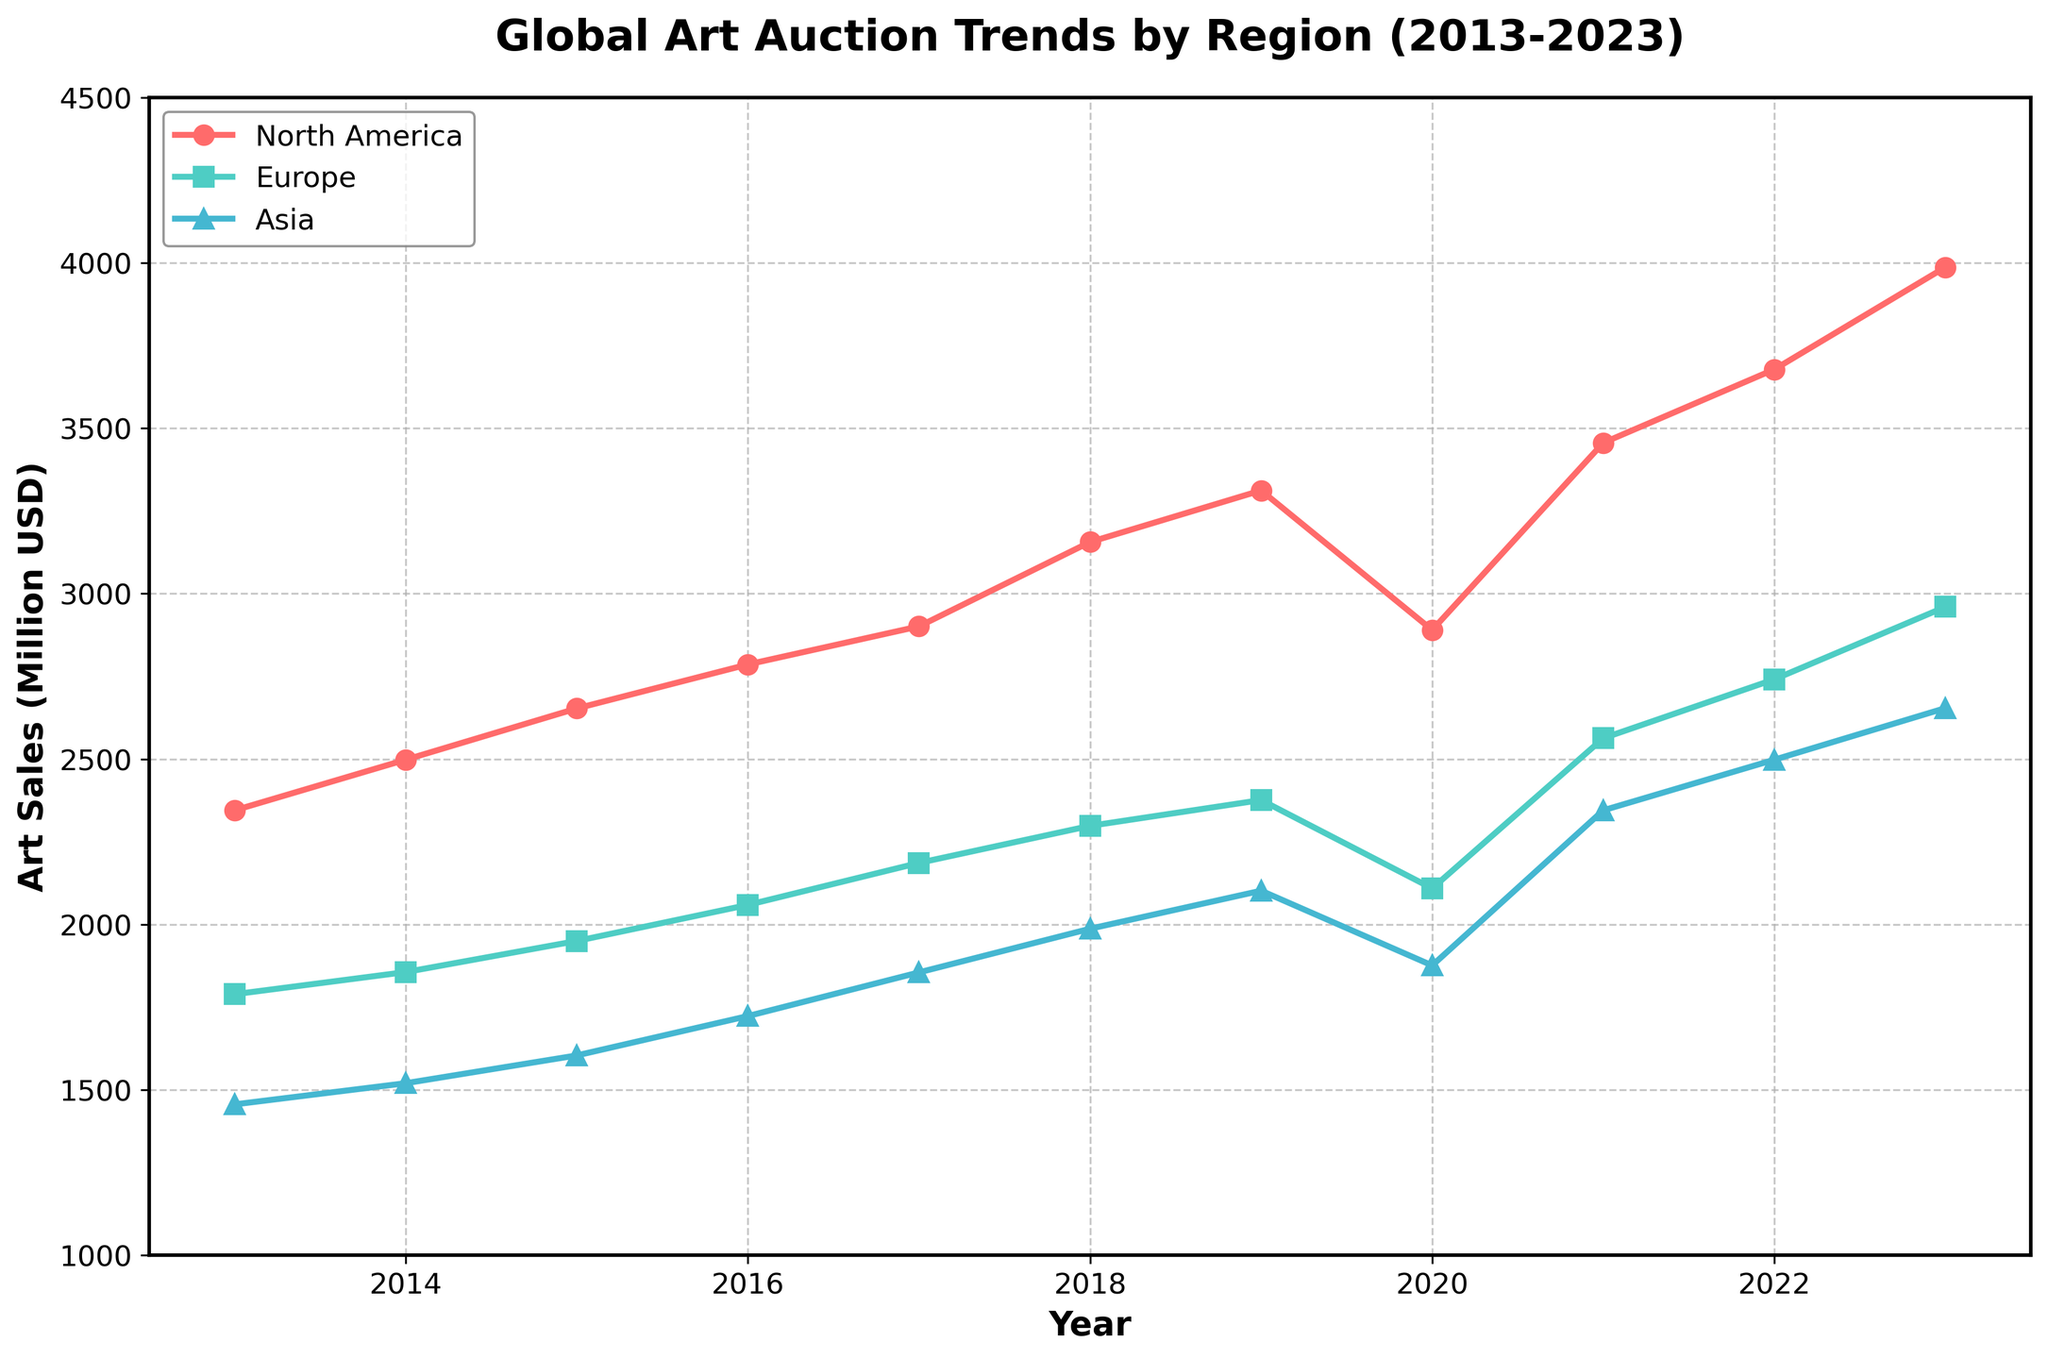What is the title of the figure? The title of the figure is usually the text at the very top that describes the overall content. In this case, it summarizes the trends being displayed.
Answer: Global Art Auction Trends by Region (2013-2023) What regions are represented in the figure? The legend in the figure shows the names of all regions that are included in the plot.
Answer: North America, Europe, Asia Which region had the highest art sales in 2023? Look at the end of the time series for each region (2023) and identify the one with the highest value.
Answer: North America In which year did Europe have the highest art sales? Identify the peak on the line corresponding to Europe in the graph and check which year it occurred.
Answer: 2023 By how much did art sales in Asia increase from 2013 to 2023? Subtract the sales value of Asia in 2013 from the sales value in 2023. The sales in 2013 are 1456 million USD, and in 2023 are 2654 million USD. So, 2654 - 1456 = 1198 million USD.
Answer: 1198 million USD Which year saw a decline in art sales in all three regions? Identify the year where all three regions have lower values compared to the previous year. This year is 2020.
Answer: 2020 Compare the art sales in North America and Europe in 2018. Which region had higher sales and by how much? Check the art sales values for both North America and Europe in 2018. North America had 3156 million USD, and Europe had 2298 million USD. The difference is 3156 - 2298 = 858 million USD.
Answer: North America by 858 million USD What is the average art sales value for Europe over the 10-year period? Sum the annual sales values for Europe from 2013 to 2023 and then divide by the number of years (11). The sum is 1789 + 1856 + 1950 + 2059 + 2186 + 2298 + 2376 + 2109 + 2563 + 2741 + 2960 = 24887 million USD. Divide by 11 to get the average: 24887 / 11 ≈ 2262 million USD.
Answer: 2262 million USD Did any region experience a consistent increase every year? Check the trends for each region to see if there is a region that continuously goes upwards every year without any decrease. No such region exists; all regions have years with declines.
Answer: No If you had to invest in art in one of these regions based on the last decade's performance, which region would you consider? Analyse the overall trends and growth rates of each region over the last decade. North America generally shows the highest values and steady increases, despite a dip in 2020.
Answer: North America 